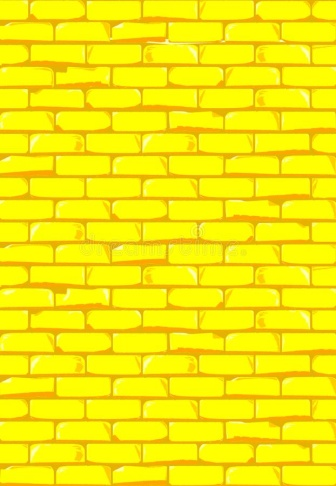Describe the following image. The image presents a close-up view of a yellow brick wall. The bricks are uniformly shaped and arranged in a staggered pattern, creating a sense of rhythm and order. The mortar that binds the bricks together is white, providing a stark contrast to the yellow bricks. The wall appears to be in good condition, with no visible signs of wear or damage. The image is taken from a straight-on angle, giving a full view of the wall. The wall fills the entire frame of the image, emphasizing its texture and pattern. There are no texts or other objects in the image. The relative positions of the bricks are consistent, maintaining the integrity of the wall structure. 